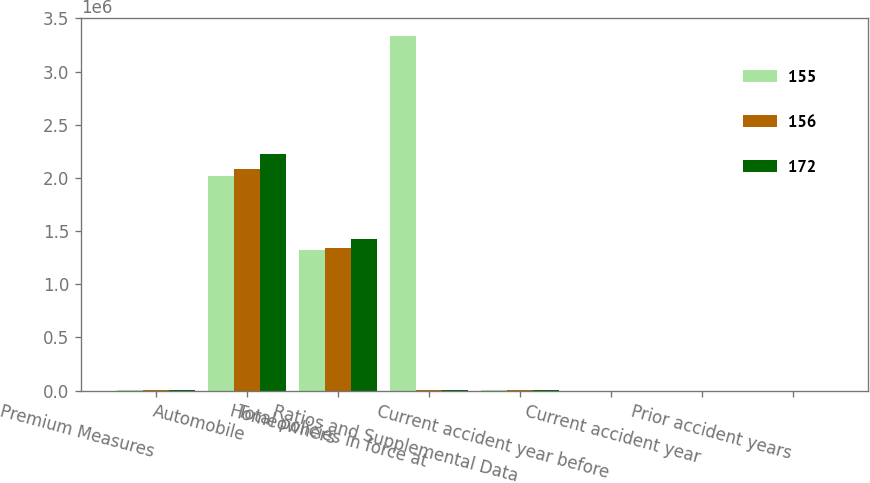Convert chart. <chart><loc_0><loc_0><loc_500><loc_500><stacked_bar_chart><ecel><fcel>Premium Measures<fcel>Automobile<fcel>Homeowners<fcel>Total policies in force at<fcel>Ratios and Supplemental Data<fcel>Current accident year before<fcel>Current accident year<fcel>Prior accident years<nl><fcel>155<fcel>2012<fcel>2.01532e+06<fcel>1.3191e+06<fcel>3.33442e+06<fcel>2012<fcel>65.7<fcel>10.5<fcel>3.9<nl><fcel>156<fcel>2011<fcel>2.08054e+06<fcel>1.33868e+06<fcel>2010.5<fcel>2011<fcel>67.7<fcel>11.3<fcel>2<nl><fcel>172<fcel>2010<fcel>2.22635e+06<fcel>1.42611e+06<fcel>2010.5<fcel>2010<fcel>69.4<fcel>7.6<fcel>2.2<nl></chart> 